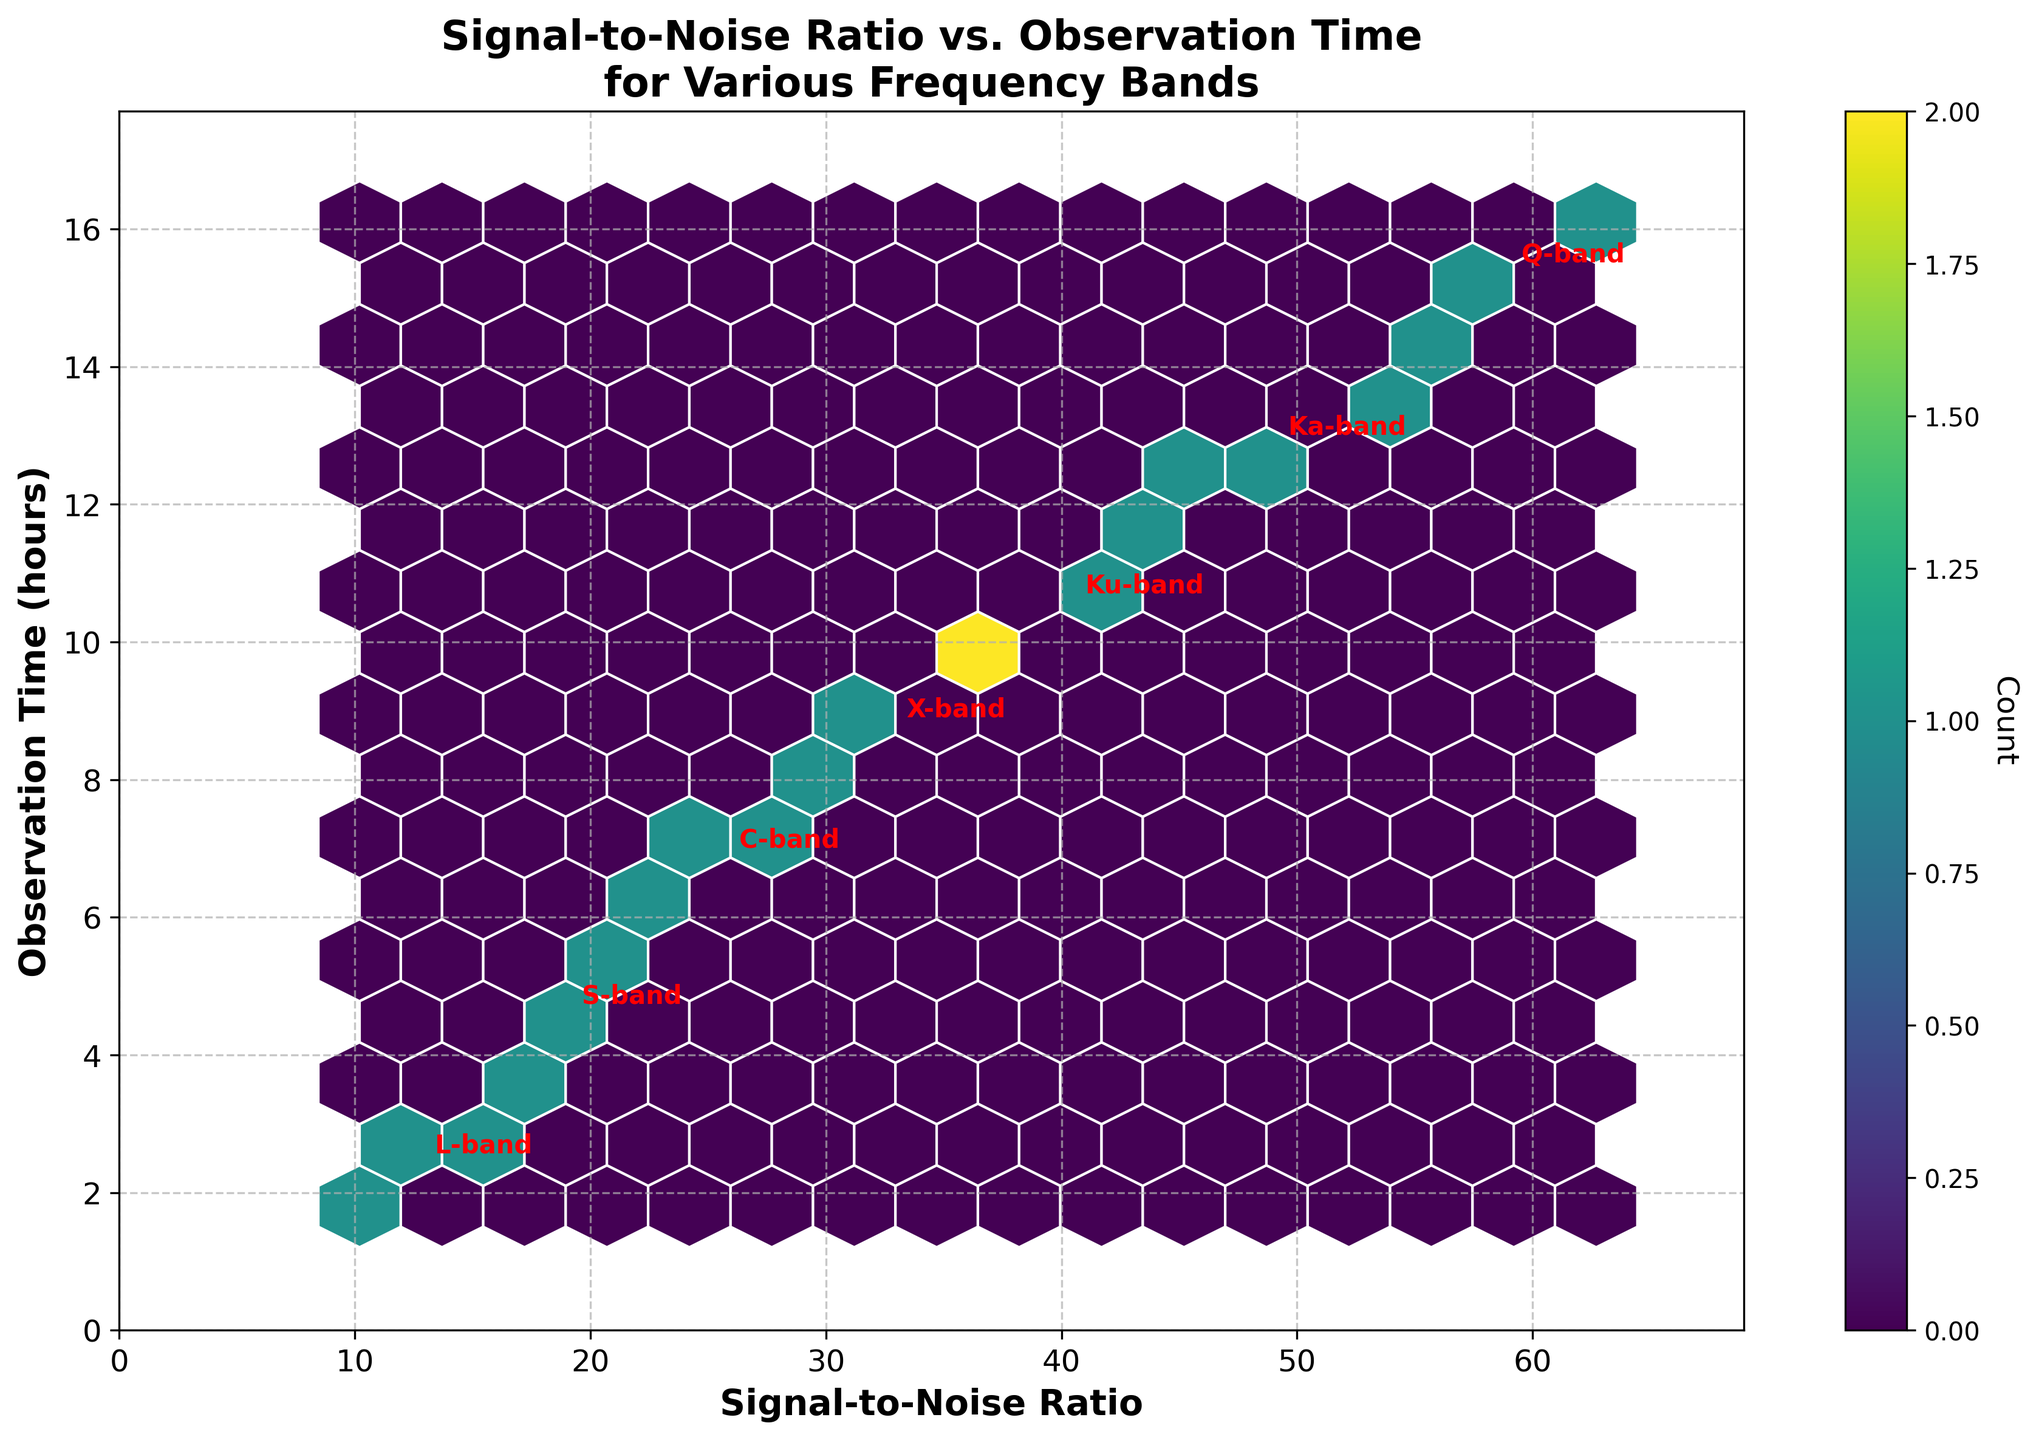What is the title of the plot? The title of the plot is found at the top of the figure. It explains what the plot is about.
Answer: Signal-to-Noise Ratio vs. Observation Time for Various Frequency Bands What are the labels of the x-axis and y-axis? The labels of the x-axis and y-axis are located along their respective axes. They indicate the variables being plotted.
Answer: Signal-to-Noise Ratio, Observation Time (hours) Which color represents the highest count in the hexbin plot? The color representing the highest count can be determined by looking at the colorbar. The color at the top of the colorbar (the rightmost side) represents the highest count.
Answer: Yellow How many frequency bands are annotated in the plot? The frequency bands are annotated in red text on the plot. Count these annotations.
Answer: Six What is the range of the observation time values depicted? The range of the observation time values can be determined by looking at the y-axis.
Answer: 0 to around 16.5 hours What is the average signal-to-noise ratio and observation time for the L-band? Locate the annotation for the L-band and read the values next to it.
Answer: Mean signal-to-noise ratio: approximately 13, Mean observation time: approximately 2.4 hours Which frequency band has the highest average observation time? Look for the annotation with the highest observation time value among all frequency bands.
Answer: Q-band What is the relationship trend between signal-to-noise ratio and observation time? Observe the overall distribution of data points in the hexbin plot.
Answer: They are positively correlated Between the Ku-band and Ka-band, which one has a higher average signal-to-noise ratio? Locate the annotations for Ku-band and Ka-band and compare their average signal-to-noise ratio values.
Answer: Ka-band Does the C-band show a wider range of signal-to-noise ratio or observation time compared to the S-band? Compare the spread of data points for C-band and S-band in both the x and y dimensions.
Answer: Signal-to-noise ratio is wider for C-band, observation time is wider for S-band 